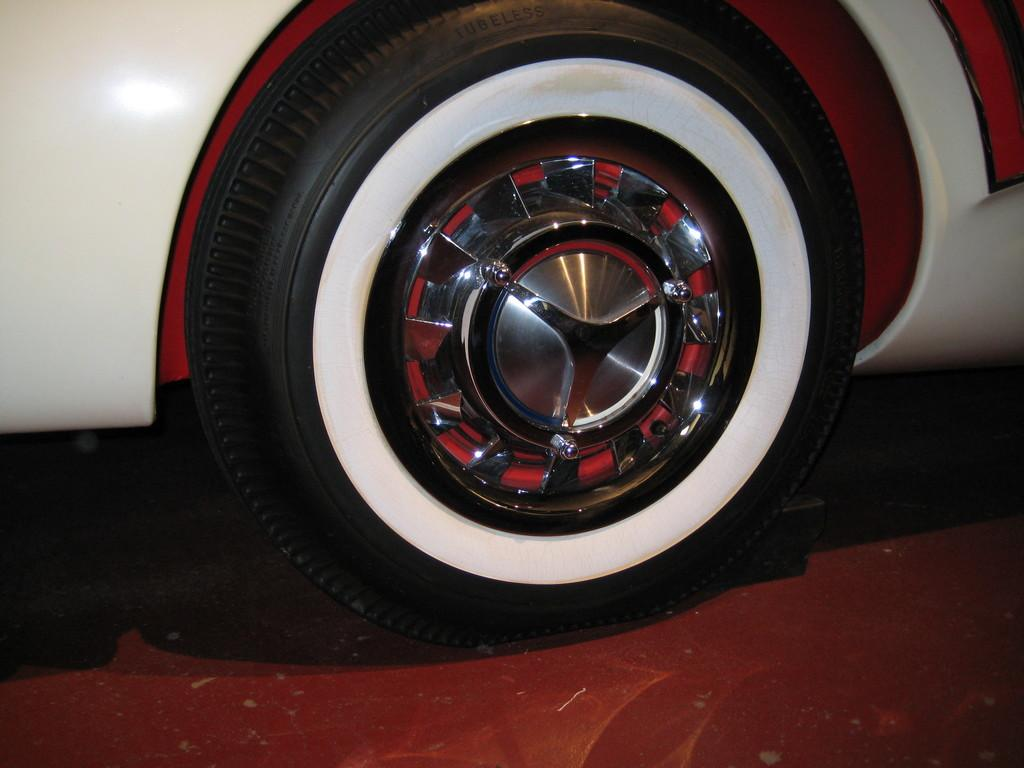What object is present in the image that is related to a car? The image contains a car tyre. What colors can be seen on the car tyre? The car tyre has white, black, and silver colors. What color is the car in the image? The car in the image is white. Can you see any worms crawling on the car tyre in the image? There are no worms present in the image; it only features a car tyre and a white car. What type of channel is depicted in the image? There is no channel present in the image; it only contains a car tyre and a white car. 